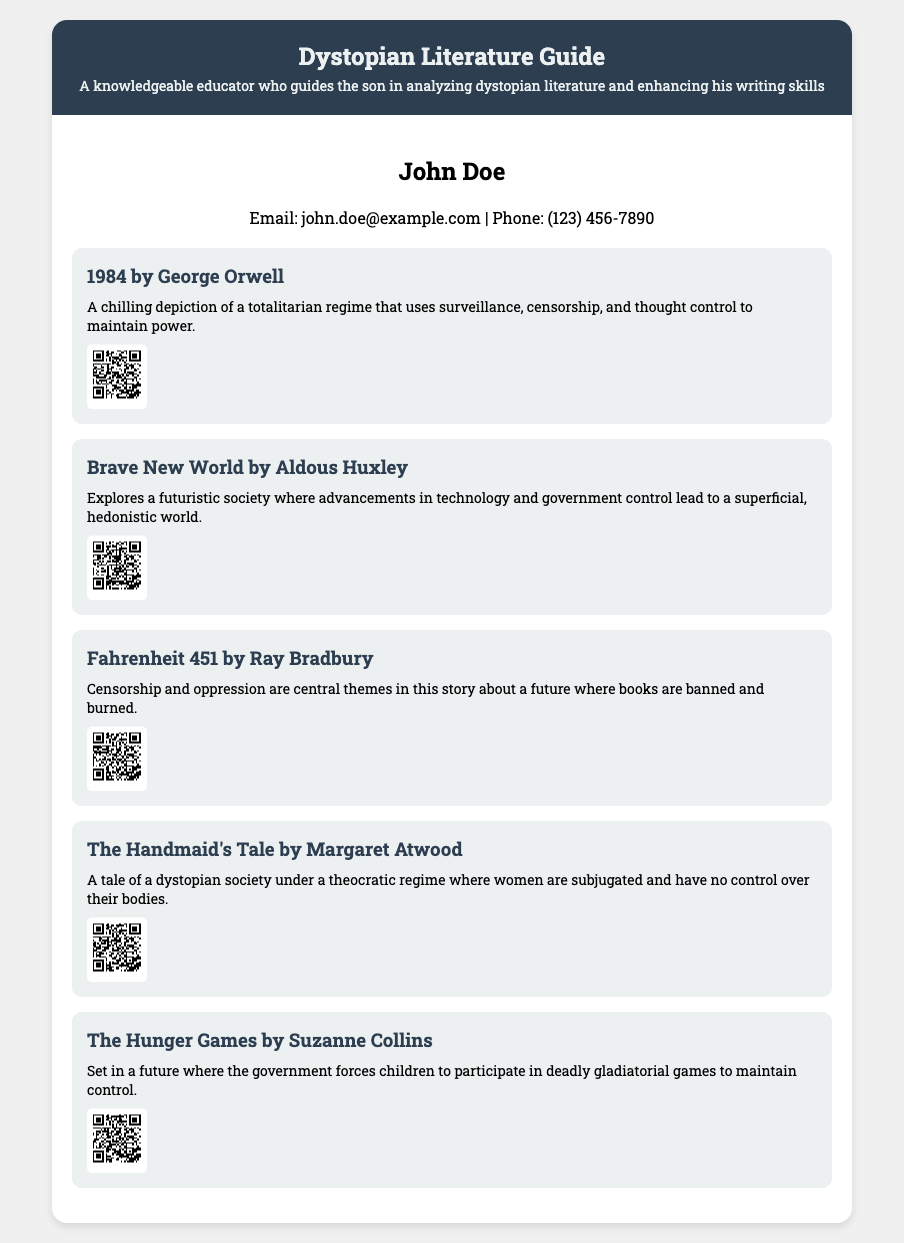What is the title of the document? The title is prominently displayed at the top of the document, indicating its focus.
Answer: Dystopian Literature Guide Who is the author of "1984"? The document lists the author of "1984" explicitly in the summary of the novel.
Answer: George Orwell How many dystopian novels are summarized in the document? The document contains five distinct summaries, each for a different novel.
Answer: Five What is the main theme of "Fahrenheit 451"? The document describes the central theme of censorship in the summary of the novel.
Answer: Censorship What type of society is depicted in "The Handmaid's Tale"? The summary explicitly states that the society in "The Handmaid's Tale" is theocratic and repressive.
Answer: Theocratic What does the QR code for "Brave New World" link to? The QR code is associated with the specific online resource for "Brave New World" provided in the document.
Answer: https://example.com/resource/brave_new_world Who can be contacted for more information? The contact information section provides the name of the person for inquiries.
Answer: John Doe What color is the header of the business card? The styling details for the header are described in the CSS and visual layout in the document.
Answer: Dark blue What genre does this document belong to? The content presented in the document clearly falls under a particular literary category.
Answer: Dystopian literature 